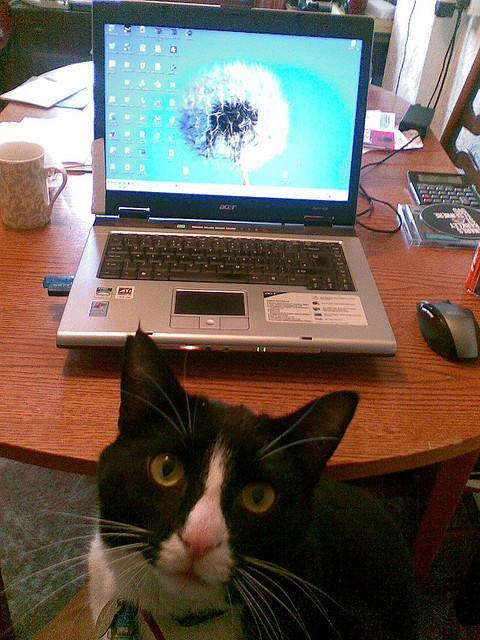How many pets are shown?
Give a very brief answer. 1. How many cats can be seen?
Give a very brief answer. 1. 